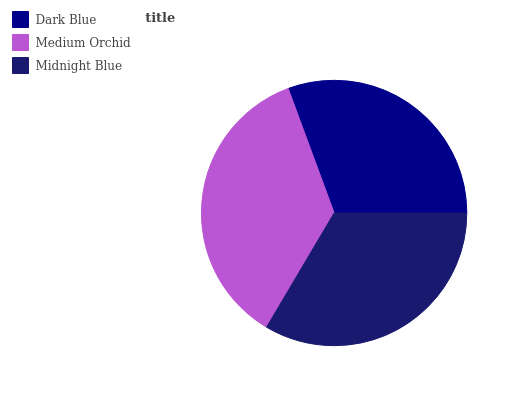Is Dark Blue the minimum?
Answer yes or no. Yes. Is Medium Orchid the maximum?
Answer yes or no. Yes. Is Midnight Blue the minimum?
Answer yes or no. No. Is Midnight Blue the maximum?
Answer yes or no. No. Is Medium Orchid greater than Midnight Blue?
Answer yes or no. Yes. Is Midnight Blue less than Medium Orchid?
Answer yes or no. Yes. Is Midnight Blue greater than Medium Orchid?
Answer yes or no. No. Is Medium Orchid less than Midnight Blue?
Answer yes or no. No. Is Midnight Blue the high median?
Answer yes or no. Yes. Is Midnight Blue the low median?
Answer yes or no. Yes. Is Medium Orchid the high median?
Answer yes or no. No. Is Medium Orchid the low median?
Answer yes or no. No. 